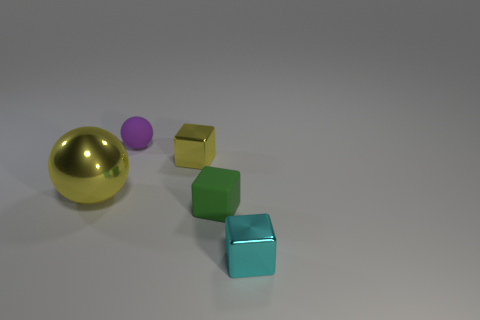There is a matte block; is its size the same as the sphere behind the big metallic sphere?
Give a very brief answer. Yes. There is a metal object that is both right of the tiny matte ball and behind the cyan block; what is its color?
Keep it short and to the point. Yellow. What number of other things are the same shape as the large object?
Provide a short and direct response. 1. Is the color of the tiny metal block that is behind the large yellow ball the same as the ball that is in front of the purple rubber thing?
Your answer should be very brief. Yes. Does the matte thing behind the big yellow metal ball have the same size as the block that is behind the green thing?
Give a very brief answer. Yes. What is the material of the object behind the small shiny block that is to the left of the metallic block that is in front of the yellow sphere?
Offer a very short reply. Rubber. Does the small yellow object have the same shape as the tiny cyan object?
Ensure brevity in your answer.  Yes. There is a green object that is the same shape as the tiny yellow metal thing; what material is it?
Provide a short and direct response. Rubber. How many small cubes are the same color as the metallic ball?
Your answer should be very brief. 1. There is a yellow sphere that is made of the same material as the small cyan cube; what size is it?
Offer a terse response. Large. 